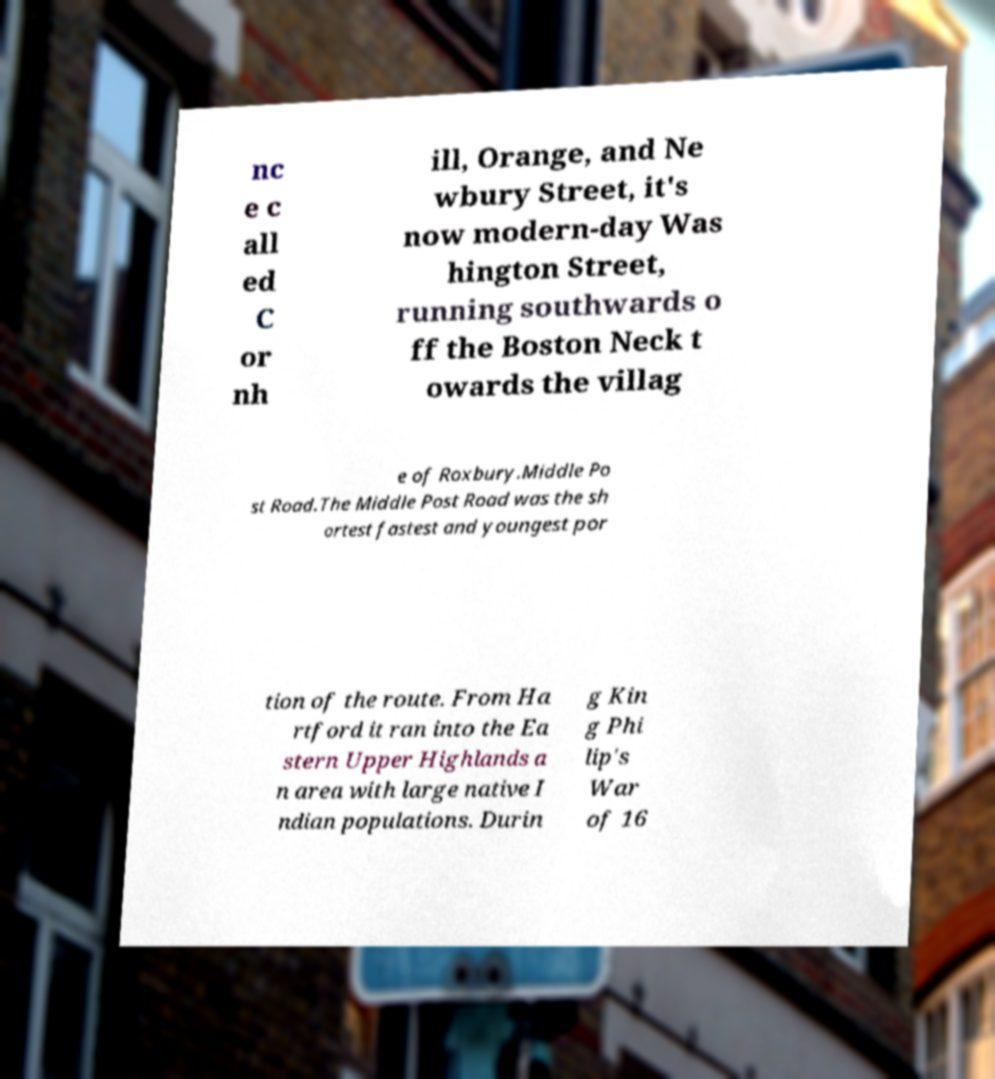Could you extract and type out the text from this image? nc e c all ed C or nh ill, Orange, and Ne wbury Street, it's now modern-day Was hington Street, running southwards o ff the Boston Neck t owards the villag e of Roxbury.Middle Po st Road.The Middle Post Road was the sh ortest fastest and youngest por tion of the route. From Ha rtford it ran into the Ea stern Upper Highlands a n area with large native I ndian populations. Durin g Kin g Phi lip's War of 16 